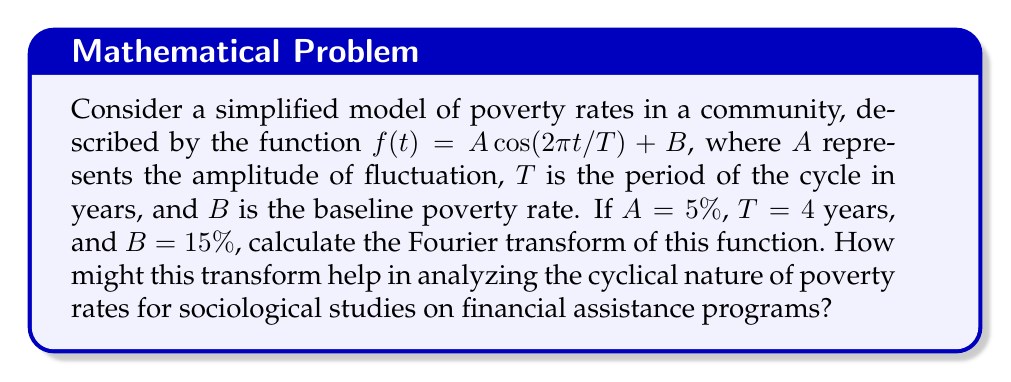Show me your answer to this math problem. To solve this problem, we'll follow these steps:

1) First, let's recall the general form of the Fourier transform:

   $$F(\omega) = \int_{-\infty}^{\infty} f(t) e^{-i\omega t} dt$$

2) Our function is:

   $$f(t) = A \cos(2\pi t/T) + B = 0.05 \cos(\pi t/2) + 0.15$$

3) We can rewrite this using Euler's formula: $\cos(\theta) = \frac{1}{2}(e^{i\theta} + e^{-i\theta})$

   $$f(t) = 0.025(e^{i\pi t/2} + e^{-i\pi t/2}) + 0.15$$

4) Now, let's compute the Fourier transform:

   $$F(\omega) = \int_{-\infty}^{\infty} [0.025(e^{i\pi t/2} + e^{-i\pi t/2}) + 0.15] e^{-i\omega t} dt$$

5) This can be split into three integrals:

   $$F(\omega) = 0.025 \int_{-\infty}^{\infty} e^{i(\pi/2 - \omega)t} dt + 0.025 \int_{-\infty}^{\infty} e^{-i(\pi/2 + \omega)t} dt + 0.15 \int_{-\infty}^{\infty} e^{-i\omega t} dt$$

6) Recall that $\int_{-\infty}^{\infty} e^{iax} dx = 2\pi \delta(a)$, where $\delta$ is the Dirac delta function:

   $$F(\omega) = 0.025 \cdot 2\pi \delta(\pi/2 - \omega) + 0.025 \cdot 2\pi \delta(-\pi/2 - \omega) + 0.15 \cdot 2\pi \delta(-\omega)$$

7) Simplify:

   $$F(\omega) = 0.05\pi [\delta(\omega - \pi/2) + \delta(\omega + \pi/2)] + 0.3\pi \delta(\omega)$$

This Fourier transform shows three spikes: one at $\omega = 0$ (representing the constant term), and two at $\omega = \pm \pi/2$ (representing the cosine term). The amplitude of these spikes corresponds to the coefficients in our original function.

For sociological studies, this transform helps in:
1) Identifying the dominant frequency of poverty rate fluctuations (here, $\omega = \pi/2$, corresponding to a 4-year cycle).
2) Quantifying the strength of cyclical patterns vs. constant trends (comparing the heights of the spikes).
3) Potentially revealing hidden periodicities in more complex real-world data.
4) Facilitating comparison between different communities or time periods.
Answer: $$F(\omega) = 0.05\pi [\delta(\omega - \pi/2) + \delta(\omega + \pi/2)] + 0.3\pi \delta(\omega)$$ 